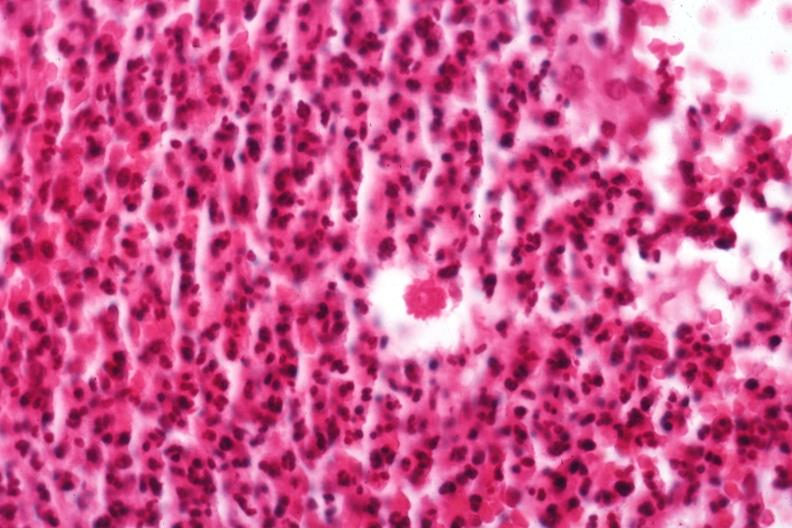does this image show organism?
Answer the question using a single word or phrase. Yes 